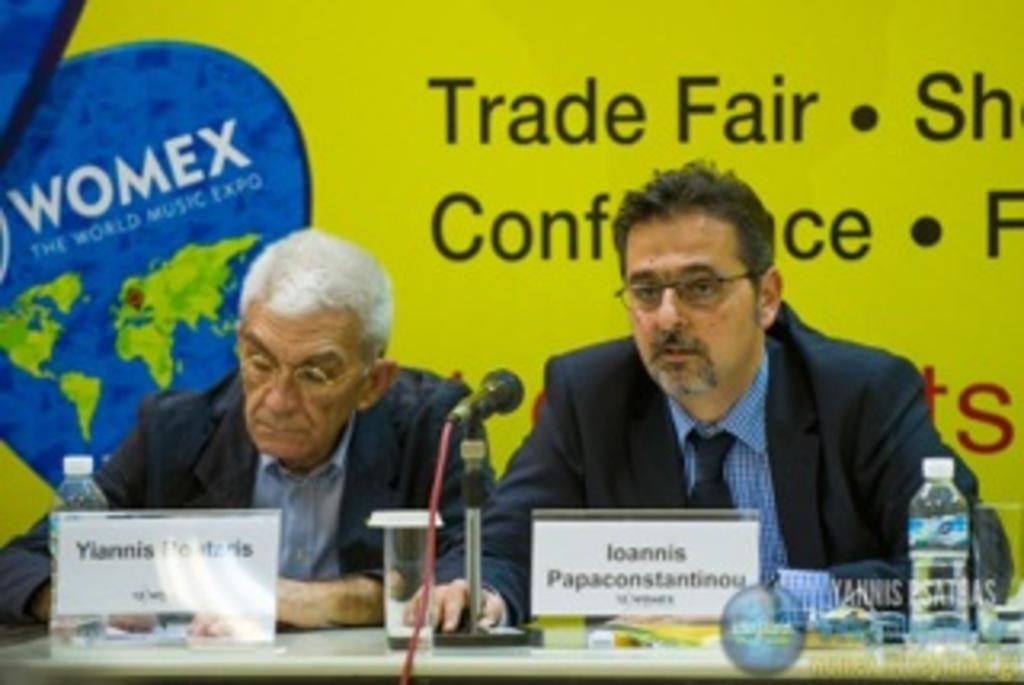How many people are in the image? There are two men in the image. What are the men doing in the image? The men are sitting on chairs in the image. Where are the chairs located? The chairs are at a table in the image. What items can be seen on the table? There are water bottles, water glasses, a mic on a stand, and two name boards on the table. What is visible in the background of the image? There is a banner in the background of the image. What type of beetle can be seen crawling on the mic stand in the image? There is no beetle present in the image; the mic stand is clear of any insects. What type of shoes are the men wearing in the image? The image does not show the men's shoes, so it cannot be determined from the picture. 